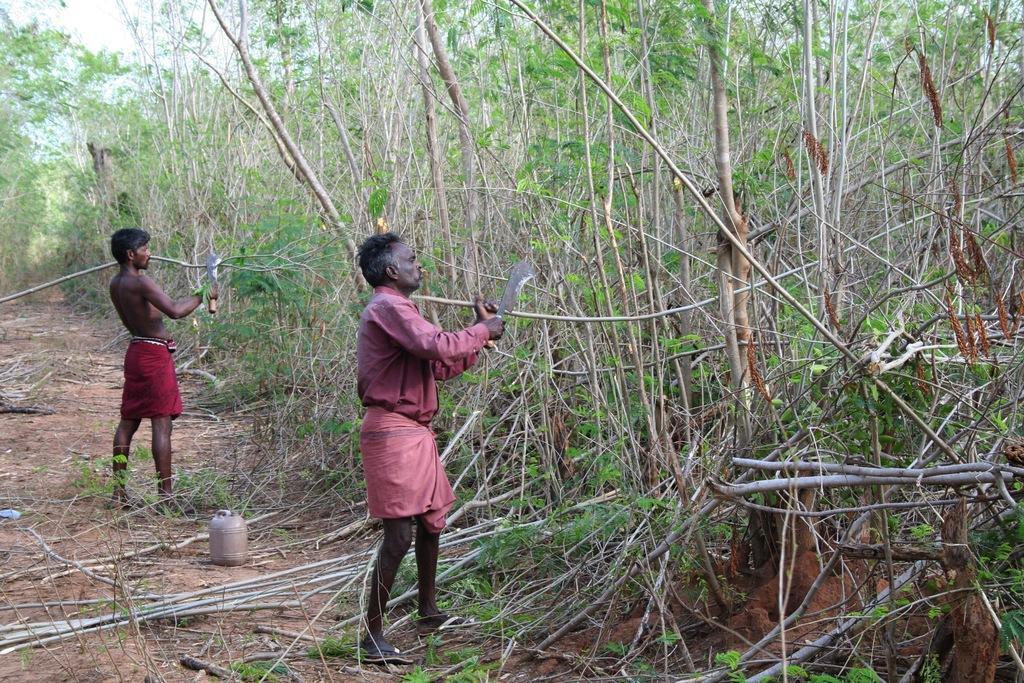Please provide a concise description of this image. In this image I can see two people are holding the branches and something. I can see few trees, mud, sky and few objects on the ground. 